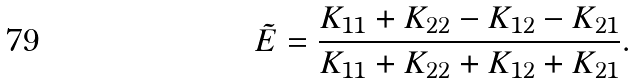Convert formula to latex. <formula><loc_0><loc_0><loc_500><loc_500>\tilde { E } = \frac { K _ { 1 1 } + K _ { 2 2 } - K _ { 1 2 } - K _ { 2 1 } } { K _ { 1 1 } + K _ { 2 2 } + K _ { 1 2 } + K _ { 2 1 } } .</formula> 